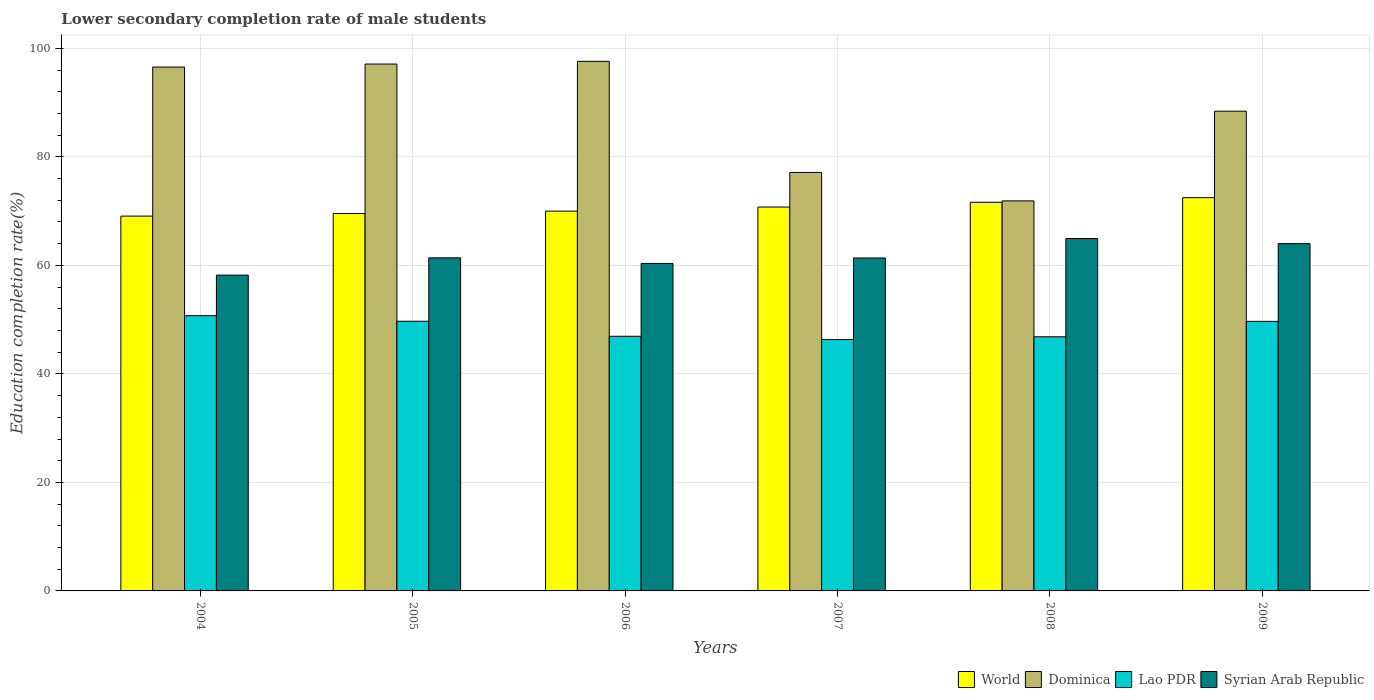How many groups of bars are there?
Your response must be concise. 6. In how many cases, is the number of bars for a given year not equal to the number of legend labels?
Offer a very short reply. 0. What is the lower secondary completion rate of male students in Lao PDR in 2009?
Provide a succinct answer. 49.68. Across all years, what is the maximum lower secondary completion rate of male students in Syrian Arab Republic?
Offer a terse response. 64.95. Across all years, what is the minimum lower secondary completion rate of male students in Dominica?
Ensure brevity in your answer.  71.89. In which year was the lower secondary completion rate of male students in World minimum?
Keep it short and to the point. 2004. What is the total lower secondary completion rate of male students in Dominica in the graph?
Offer a very short reply. 528.71. What is the difference between the lower secondary completion rate of male students in World in 2005 and that in 2009?
Your answer should be compact. -2.91. What is the difference between the lower secondary completion rate of male students in Dominica in 2005 and the lower secondary completion rate of male students in World in 2006?
Offer a terse response. 27.11. What is the average lower secondary completion rate of male students in World per year?
Ensure brevity in your answer.  70.58. In the year 2009, what is the difference between the lower secondary completion rate of male students in Dominica and lower secondary completion rate of male students in World?
Give a very brief answer. 15.95. In how many years, is the lower secondary completion rate of male students in Syrian Arab Republic greater than 52 %?
Provide a short and direct response. 6. What is the ratio of the lower secondary completion rate of male students in Lao PDR in 2005 to that in 2006?
Ensure brevity in your answer.  1.06. Is the lower secondary completion rate of male students in World in 2008 less than that in 2009?
Offer a very short reply. Yes. What is the difference between the highest and the second highest lower secondary completion rate of male students in Syrian Arab Republic?
Give a very brief answer. 0.94. What is the difference between the highest and the lowest lower secondary completion rate of male students in Syrian Arab Republic?
Provide a short and direct response. 6.74. In how many years, is the lower secondary completion rate of male students in Syrian Arab Republic greater than the average lower secondary completion rate of male students in Syrian Arab Republic taken over all years?
Your response must be concise. 2. What does the 2nd bar from the left in 2005 represents?
Offer a very short reply. Dominica. What does the 2nd bar from the right in 2006 represents?
Your response must be concise. Lao PDR. How many bars are there?
Make the answer very short. 24. Are all the bars in the graph horizontal?
Give a very brief answer. No. Does the graph contain any zero values?
Provide a succinct answer. No. How many legend labels are there?
Keep it short and to the point. 4. How are the legend labels stacked?
Provide a succinct answer. Horizontal. What is the title of the graph?
Provide a short and direct response. Lower secondary completion rate of male students. Does "Lao PDR" appear as one of the legend labels in the graph?
Give a very brief answer. Yes. What is the label or title of the Y-axis?
Offer a very short reply. Education completion rate(%). What is the Education completion rate(%) in World in 2004?
Keep it short and to the point. 69.08. What is the Education completion rate(%) of Dominica in 2004?
Make the answer very short. 96.56. What is the Education completion rate(%) in Lao PDR in 2004?
Provide a short and direct response. 50.73. What is the Education completion rate(%) of Syrian Arab Republic in 2004?
Your response must be concise. 58.21. What is the Education completion rate(%) of World in 2005?
Provide a succinct answer. 69.56. What is the Education completion rate(%) in Dominica in 2005?
Your answer should be very brief. 97.11. What is the Education completion rate(%) of Lao PDR in 2005?
Your answer should be compact. 49.7. What is the Education completion rate(%) in Syrian Arab Republic in 2005?
Your response must be concise. 61.39. What is the Education completion rate(%) of World in 2006?
Offer a terse response. 70. What is the Education completion rate(%) of Dominica in 2006?
Offer a very short reply. 97.6. What is the Education completion rate(%) in Lao PDR in 2006?
Your response must be concise. 46.93. What is the Education completion rate(%) of Syrian Arab Republic in 2006?
Offer a terse response. 60.36. What is the Education completion rate(%) of World in 2007?
Your answer should be very brief. 70.75. What is the Education completion rate(%) of Dominica in 2007?
Offer a terse response. 77.13. What is the Education completion rate(%) in Lao PDR in 2007?
Provide a succinct answer. 46.33. What is the Education completion rate(%) of Syrian Arab Republic in 2007?
Keep it short and to the point. 61.36. What is the Education completion rate(%) of World in 2008?
Provide a short and direct response. 71.63. What is the Education completion rate(%) in Dominica in 2008?
Ensure brevity in your answer.  71.89. What is the Education completion rate(%) in Lao PDR in 2008?
Your answer should be compact. 46.84. What is the Education completion rate(%) of Syrian Arab Republic in 2008?
Provide a short and direct response. 64.95. What is the Education completion rate(%) of World in 2009?
Ensure brevity in your answer.  72.48. What is the Education completion rate(%) of Dominica in 2009?
Keep it short and to the point. 88.42. What is the Education completion rate(%) of Lao PDR in 2009?
Make the answer very short. 49.68. What is the Education completion rate(%) of Syrian Arab Republic in 2009?
Make the answer very short. 64.01. Across all years, what is the maximum Education completion rate(%) of World?
Your response must be concise. 72.48. Across all years, what is the maximum Education completion rate(%) of Dominica?
Your response must be concise. 97.6. Across all years, what is the maximum Education completion rate(%) in Lao PDR?
Ensure brevity in your answer.  50.73. Across all years, what is the maximum Education completion rate(%) in Syrian Arab Republic?
Provide a short and direct response. 64.95. Across all years, what is the minimum Education completion rate(%) in World?
Your answer should be very brief. 69.08. Across all years, what is the minimum Education completion rate(%) of Dominica?
Give a very brief answer. 71.89. Across all years, what is the minimum Education completion rate(%) of Lao PDR?
Keep it short and to the point. 46.33. Across all years, what is the minimum Education completion rate(%) in Syrian Arab Republic?
Your answer should be compact. 58.21. What is the total Education completion rate(%) of World in the graph?
Offer a very short reply. 423.51. What is the total Education completion rate(%) in Dominica in the graph?
Provide a short and direct response. 528.71. What is the total Education completion rate(%) in Lao PDR in the graph?
Your answer should be compact. 290.22. What is the total Education completion rate(%) in Syrian Arab Republic in the graph?
Provide a succinct answer. 370.28. What is the difference between the Education completion rate(%) in World in 2004 and that in 2005?
Give a very brief answer. -0.48. What is the difference between the Education completion rate(%) of Dominica in 2004 and that in 2005?
Make the answer very short. -0.55. What is the difference between the Education completion rate(%) in Lao PDR in 2004 and that in 2005?
Your response must be concise. 1.03. What is the difference between the Education completion rate(%) of Syrian Arab Republic in 2004 and that in 2005?
Give a very brief answer. -3.18. What is the difference between the Education completion rate(%) of World in 2004 and that in 2006?
Ensure brevity in your answer.  -0.92. What is the difference between the Education completion rate(%) of Dominica in 2004 and that in 2006?
Your answer should be compact. -1.05. What is the difference between the Education completion rate(%) of Lao PDR in 2004 and that in 2006?
Your answer should be very brief. 3.8. What is the difference between the Education completion rate(%) in Syrian Arab Republic in 2004 and that in 2006?
Your answer should be compact. -2.15. What is the difference between the Education completion rate(%) in World in 2004 and that in 2007?
Provide a short and direct response. -1.66. What is the difference between the Education completion rate(%) of Dominica in 2004 and that in 2007?
Ensure brevity in your answer.  19.42. What is the difference between the Education completion rate(%) in Lao PDR in 2004 and that in 2007?
Your answer should be compact. 4.4. What is the difference between the Education completion rate(%) of Syrian Arab Republic in 2004 and that in 2007?
Your answer should be compact. -3.16. What is the difference between the Education completion rate(%) of World in 2004 and that in 2008?
Your answer should be compact. -2.55. What is the difference between the Education completion rate(%) of Dominica in 2004 and that in 2008?
Give a very brief answer. 24.67. What is the difference between the Education completion rate(%) in Lao PDR in 2004 and that in 2008?
Provide a short and direct response. 3.89. What is the difference between the Education completion rate(%) in Syrian Arab Republic in 2004 and that in 2008?
Your response must be concise. -6.74. What is the difference between the Education completion rate(%) in World in 2004 and that in 2009?
Give a very brief answer. -3.39. What is the difference between the Education completion rate(%) in Dominica in 2004 and that in 2009?
Give a very brief answer. 8.14. What is the difference between the Education completion rate(%) of Lao PDR in 2004 and that in 2009?
Give a very brief answer. 1.05. What is the difference between the Education completion rate(%) of Syrian Arab Republic in 2004 and that in 2009?
Keep it short and to the point. -5.8. What is the difference between the Education completion rate(%) of World in 2005 and that in 2006?
Ensure brevity in your answer.  -0.44. What is the difference between the Education completion rate(%) of Dominica in 2005 and that in 2006?
Keep it short and to the point. -0.5. What is the difference between the Education completion rate(%) in Lao PDR in 2005 and that in 2006?
Give a very brief answer. 2.77. What is the difference between the Education completion rate(%) of Syrian Arab Republic in 2005 and that in 2006?
Your answer should be very brief. 1.03. What is the difference between the Education completion rate(%) of World in 2005 and that in 2007?
Make the answer very short. -1.18. What is the difference between the Education completion rate(%) in Dominica in 2005 and that in 2007?
Keep it short and to the point. 19.98. What is the difference between the Education completion rate(%) of Lao PDR in 2005 and that in 2007?
Your response must be concise. 3.38. What is the difference between the Education completion rate(%) of Syrian Arab Republic in 2005 and that in 2007?
Your answer should be very brief. 0.02. What is the difference between the Education completion rate(%) in World in 2005 and that in 2008?
Make the answer very short. -2.07. What is the difference between the Education completion rate(%) of Dominica in 2005 and that in 2008?
Give a very brief answer. 25.22. What is the difference between the Education completion rate(%) in Lao PDR in 2005 and that in 2008?
Your answer should be compact. 2.86. What is the difference between the Education completion rate(%) of Syrian Arab Republic in 2005 and that in 2008?
Ensure brevity in your answer.  -3.56. What is the difference between the Education completion rate(%) of World in 2005 and that in 2009?
Your answer should be very brief. -2.91. What is the difference between the Education completion rate(%) of Dominica in 2005 and that in 2009?
Your answer should be very brief. 8.69. What is the difference between the Education completion rate(%) in Lao PDR in 2005 and that in 2009?
Your answer should be compact. 0.02. What is the difference between the Education completion rate(%) in Syrian Arab Republic in 2005 and that in 2009?
Offer a very short reply. -2.62. What is the difference between the Education completion rate(%) in World in 2006 and that in 2007?
Your response must be concise. -0.75. What is the difference between the Education completion rate(%) in Dominica in 2006 and that in 2007?
Offer a very short reply. 20.47. What is the difference between the Education completion rate(%) of Lao PDR in 2006 and that in 2007?
Your answer should be compact. 0.61. What is the difference between the Education completion rate(%) of Syrian Arab Republic in 2006 and that in 2007?
Keep it short and to the point. -1.01. What is the difference between the Education completion rate(%) of World in 2006 and that in 2008?
Offer a very short reply. -1.63. What is the difference between the Education completion rate(%) of Dominica in 2006 and that in 2008?
Provide a short and direct response. 25.72. What is the difference between the Education completion rate(%) of Lao PDR in 2006 and that in 2008?
Keep it short and to the point. 0.09. What is the difference between the Education completion rate(%) of Syrian Arab Republic in 2006 and that in 2008?
Your answer should be compact. -4.59. What is the difference between the Education completion rate(%) in World in 2006 and that in 2009?
Your answer should be very brief. -2.47. What is the difference between the Education completion rate(%) of Dominica in 2006 and that in 2009?
Keep it short and to the point. 9.18. What is the difference between the Education completion rate(%) of Lao PDR in 2006 and that in 2009?
Your response must be concise. -2.75. What is the difference between the Education completion rate(%) of Syrian Arab Republic in 2006 and that in 2009?
Offer a terse response. -3.65. What is the difference between the Education completion rate(%) of World in 2007 and that in 2008?
Offer a very short reply. -0.88. What is the difference between the Education completion rate(%) in Dominica in 2007 and that in 2008?
Offer a very short reply. 5.24. What is the difference between the Education completion rate(%) in Lao PDR in 2007 and that in 2008?
Your answer should be compact. -0.52. What is the difference between the Education completion rate(%) of Syrian Arab Republic in 2007 and that in 2008?
Your answer should be compact. -3.59. What is the difference between the Education completion rate(%) in World in 2007 and that in 2009?
Provide a succinct answer. -1.73. What is the difference between the Education completion rate(%) in Dominica in 2007 and that in 2009?
Provide a succinct answer. -11.29. What is the difference between the Education completion rate(%) in Lao PDR in 2007 and that in 2009?
Offer a very short reply. -3.35. What is the difference between the Education completion rate(%) of Syrian Arab Republic in 2007 and that in 2009?
Give a very brief answer. -2.65. What is the difference between the Education completion rate(%) of World in 2008 and that in 2009?
Your response must be concise. -0.84. What is the difference between the Education completion rate(%) of Dominica in 2008 and that in 2009?
Your answer should be compact. -16.53. What is the difference between the Education completion rate(%) in Lao PDR in 2008 and that in 2009?
Ensure brevity in your answer.  -2.84. What is the difference between the Education completion rate(%) of Syrian Arab Republic in 2008 and that in 2009?
Make the answer very short. 0.94. What is the difference between the Education completion rate(%) of World in 2004 and the Education completion rate(%) of Dominica in 2005?
Your answer should be compact. -28.02. What is the difference between the Education completion rate(%) of World in 2004 and the Education completion rate(%) of Lao PDR in 2005?
Your answer should be very brief. 19.38. What is the difference between the Education completion rate(%) in World in 2004 and the Education completion rate(%) in Syrian Arab Republic in 2005?
Your answer should be very brief. 7.69. What is the difference between the Education completion rate(%) in Dominica in 2004 and the Education completion rate(%) in Lao PDR in 2005?
Your answer should be compact. 46.85. What is the difference between the Education completion rate(%) in Dominica in 2004 and the Education completion rate(%) in Syrian Arab Republic in 2005?
Ensure brevity in your answer.  35.17. What is the difference between the Education completion rate(%) of Lao PDR in 2004 and the Education completion rate(%) of Syrian Arab Republic in 2005?
Provide a succinct answer. -10.66. What is the difference between the Education completion rate(%) of World in 2004 and the Education completion rate(%) of Dominica in 2006?
Your answer should be compact. -28.52. What is the difference between the Education completion rate(%) of World in 2004 and the Education completion rate(%) of Lao PDR in 2006?
Offer a very short reply. 22.15. What is the difference between the Education completion rate(%) in World in 2004 and the Education completion rate(%) in Syrian Arab Republic in 2006?
Provide a short and direct response. 8.73. What is the difference between the Education completion rate(%) of Dominica in 2004 and the Education completion rate(%) of Lao PDR in 2006?
Your answer should be very brief. 49.62. What is the difference between the Education completion rate(%) in Dominica in 2004 and the Education completion rate(%) in Syrian Arab Republic in 2006?
Offer a terse response. 36.2. What is the difference between the Education completion rate(%) in Lao PDR in 2004 and the Education completion rate(%) in Syrian Arab Republic in 2006?
Your answer should be compact. -9.63. What is the difference between the Education completion rate(%) in World in 2004 and the Education completion rate(%) in Dominica in 2007?
Offer a terse response. -8.05. What is the difference between the Education completion rate(%) of World in 2004 and the Education completion rate(%) of Lao PDR in 2007?
Ensure brevity in your answer.  22.76. What is the difference between the Education completion rate(%) of World in 2004 and the Education completion rate(%) of Syrian Arab Republic in 2007?
Offer a terse response. 7.72. What is the difference between the Education completion rate(%) of Dominica in 2004 and the Education completion rate(%) of Lao PDR in 2007?
Make the answer very short. 50.23. What is the difference between the Education completion rate(%) in Dominica in 2004 and the Education completion rate(%) in Syrian Arab Republic in 2007?
Provide a short and direct response. 35.19. What is the difference between the Education completion rate(%) of Lao PDR in 2004 and the Education completion rate(%) of Syrian Arab Republic in 2007?
Provide a succinct answer. -10.63. What is the difference between the Education completion rate(%) in World in 2004 and the Education completion rate(%) in Dominica in 2008?
Offer a terse response. -2.8. What is the difference between the Education completion rate(%) in World in 2004 and the Education completion rate(%) in Lao PDR in 2008?
Provide a short and direct response. 22.24. What is the difference between the Education completion rate(%) in World in 2004 and the Education completion rate(%) in Syrian Arab Republic in 2008?
Keep it short and to the point. 4.13. What is the difference between the Education completion rate(%) of Dominica in 2004 and the Education completion rate(%) of Lao PDR in 2008?
Provide a succinct answer. 49.71. What is the difference between the Education completion rate(%) in Dominica in 2004 and the Education completion rate(%) in Syrian Arab Republic in 2008?
Offer a very short reply. 31.61. What is the difference between the Education completion rate(%) of Lao PDR in 2004 and the Education completion rate(%) of Syrian Arab Republic in 2008?
Your answer should be very brief. -14.22. What is the difference between the Education completion rate(%) in World in 2004 and the Education completion rate(%) in Dominica in 2009?
Ensure brevity in your answer.  -19.34. What is the difference between the Education completion rate(%) in World in 2004 and the Education completion rate(%) in Lao PDR in 2009?
Make the answer very short. 19.4. What is the difference between the Education completion rate(%) in World in 2004 and the Education completion rate(%) in Syrian Arab Republic in 2009?
Offer a terse response. 5.07. What is the difference between the Education completion rate(%) of Dominica in 2004 and the Education completion rate(%) of Lao PDR in 2009?
Provide a short and direct response. 46.88. What is the difference between the Education completion rate(%) of Dominica in 2004 and the Education completion rate(%) of Syrian Arab Republic in 2009?
Provide a short and direct response. 32.55. What is the difference between the Education completion rate(%) in Lao PDR in 2004 and the Education completion rate(%) in Syrian Arab Republic in 2009?
Provide a short and direct response. -13.28. What is the difference between the Education completion rate(%) in World in 2005 and the Education completion rate(%) in Dominica in 2006?
Your answer should be compact. -28.04. What is the difference between the Education completion rate(%) in World in 2005 and the Education completion rate(%) in Lao PDR in 2006?
Offer a terse response. 22.63. What is the difference between the Education completion rate(%) in World in 2005 and the Education completion rate(%) in Syrian Arab Republic in 2006?
Offer a terse response. 9.21. What is the difference between the Education completion rate(%) of Dominica in 2005 and the Education completion rate(%) of Lao PDR in 2006?
Your answer should be compact. 50.17. What is the difference between the Education completion rate(%) of Dominica in 2005 and the Education completion rate(%) of Syrian Arab Republic in 2006?
Offer a terse response. 36.75. What is the difference between the Education completion rate(%) of Lao PDR in 2005 and the Education completion rate(%) of Syrian Arab Republic in 2006?
Offer a very short reply. -10.65. What is the difference between the Education completion rate(%) in World in 2005 and the Education completion rate(%) in Dominica in 2007?
Offer a terse response. -7.57. What is the difference between the Education completion rate(%) in World in 2005 and the Education completion rate(%) in Lao PDR in 2007?
Provide a short and direct response. 23.24. What is the difference between the Education completion rate(%) of World in 2005 and the Education completion rate(%) of Syrian Arab Republic in 2007?
Provide a short and direct response. 8.2. What is the difference between the Education completion rate(%) in Dominica in 2005 and the Education completion rate(%) in Lao PDR in 2007?
Keep it short and to the point. 50.78. What is the difference between the Education completion rate(%) in Dominica in 2005 and the Education completion rate(%) in Syrian Arab Republic in 2007?
Provide a succinct answer. 35.74. What is the difference between the Education completion rate(%) of Lao PDR in 2005 and the Education completion rate(%) of Syrian Arab Republic in 2007?
Provide a succinct answer. -11.66. What is the difference between the Education completion rate(%) in World in 2005 and the Education completion rate(%) in Dominica in 2008?
Give a very brief answer. -2.32. What is the difference between the Education completion rate(%) in World in 2005 and the Education completion rate(%) in Lao PDR in 2008?
Your answer should be very brief. 22.72. What is the difference between the Education completion rate(%) of World in 2005 and the Education completion rate(%) of Syrian Arab Republic in 2008?
Provide a short and direct response. 4.61. What is the difference between the Education completion rate(%) of Dominica in 2005 and the Education completion rate(%) of Lao PDR in 2008?
Offer a very short reply. 50.26. What is the difference between the Education completion rate(%) of Dominica in 2005 and the Education completion rate(%) of Syrian Arab Republic in 2008?
Your answer should be compact. 32.16. What is the difference between the Education completion rate(%) of Lao PDR in 2005 and the Education completion rate(%) of Syrian Arab Republic in 2008?
Provide a short and direct response. -15.25. What is the difference between the Education completion rate(%) of World in 2005 and the Education completion rate(%) of Dominica in 2009?
Provide a short and direct response. -18.86. What is the difference between the Education completion rate(%) in World in 2005 and the Education completion rate(%) in Lao PDR in 2009?
Make the answer very short. 19.88. What is the difference between the Education completion rate(%) of World in 2005 and the Education completion rate(%) of Syrian Arab Republic in 2009?
Offer a very short reply. 5.55. What is the difference between the Education completion rate(%) in Dominica in 2005 and the Education completion rate(%) in Lao PDR in 2009?
Provide a succinct answer. 47.43. What is the difference between the Education completion rate(%) in Dominica in 2005 and the Education completion rate(%) in Syrian Arab Republic in 2009?
Ensure brevity in your answer.  33.1. What is the difference between the Education completion rate(%) in Lao PDR in 2005 and the Education completion rate(%) in Syrian Arab Republic in 2009?
Ensure brevity in your answer.  -14.31. What is the difference between the Education completion rate(%) of World in 2006 and the Education completion rate(%) of Dominica in 2007?
Provide a succinct answer. -7.13. What is the difference between the Education completion rate(%) in World in 2006 and the Education completion rate(%) in Lao PDR in 2007?
Your answer should be compact. 23.67. What is the difference between the Education completion rate(%) in World in 2006 and the Education completion rate(%) in Syrian Arab Republic in 2007?
Your answer should be compact. 8.64. What is the difference between the Education completion rate(%) of Dominica in 2006 and the Education completion rate(%) of Lao PDR in 2007?
Your response must be concise. 51.28. What is the difference between the Education completion rate(%) in Dominica in 2006 and the Education completion rate(%) in Syrian Arab Republic in 2007?
Your answer should be compact. 36.24. What is the difference between the Education completion rate(%) of Lao PDR in 2006 and the Education completion rate(%) of Syrian Arab Republic in 2007?
Give a very brief answer. -14.43. What is the difference between the Education completion rate(%) of World in 2006 and the Education completion rate(%) of Dominica in 2008?
Provide a short and direct response. -1.89. What is the difference between the Education completion rate(%) in World in 2006 and the Education completion rate(%) in Lao PDR in 2008?
Your answer should be compact. 23.16. What is the difference between the Education completion rate(%) in World in 2006 and the Education completion rate(%) in Syrian Arab Republic in 2008?
Provide a short and direct response. 5.05. What is the difference between the Education completion rate(%) in Dominica in 2006 and the Education completion rate(%) in Lao PDR in 2008?
Ensure brevity in your answer.  50.76. What is the difference between the Education completion rate(%) of Dominica in 2006 and the Education completion rate(%) of Syrian Arab Republic in 2008?
Ensure brevity in your answer.  32.65. What is the difference between the Education completion rate(%) in Lao PDR in 2006 and the Education completion rate(%) in Syrian Arab Republic in 2008?
Ensure brevity in your answer.  -18.02. What is the difference between the Education completion rate(%) in World in 2006 and the Education completion rate(%) in Dominica in 2009?
Provide a short and direct response. -18.42. What is the difference between the Education completion rate(%) of World in 2006 and the Education completion rate(%) of Lao PDR in 2009?
Your answer should be very brief. 20.32. What is the difference between the Education completion rate(%) in World in 2006 and the Education completion rate(%) in Syrian Arab Republic in 2009?
Give a very brief answer. 5.99. What is the difference between the Education completion rate(%) in Dominica in 2006 and the Education completion rate(%) in Lao PDR in 2009?
Your response must be concise. 47.92. What is the difference between the Education completion rate(%) of Dominica in 2006 and the Education completion rate(%) of Syrian Arab Republic in 2009?
Ensure brevity in your answer.  33.59. What is the difference between the Education completion rate(%) of Lao PDR in 2006 and the Education completion rate(%) of Syrian Arab Republic in 2009?
Ensure brevity in your answer.  -17.08. What is the difference between the Education completion rate(%) of World in 2007 and the Education completion rate(%) of Dominica in 2008?
Your answer should be very brief. -1.14. What is the difference between the Education completion rate(%) of World in 2007 and the Education completion rate(%) of Lao PDR in 2008?
Provide a succinct answer. 23.91. What is the difference between the Education completion rate(%) of World in 2007 and the Education completion rate(%) of Syrian Arab Republic in 2008?
Offer a terse response. 5.8. What is the difference between the Education completion rate(%) of Dominica in 2007 and the Education completion rate(%) of Lao PDR in 2008?
Give a very brief answer. 30.29. What is the difference between the Education completion rate(%) in Dominica in 2007 and the Education completion rate(%) in Syrian Arab Republic in 2008?
Offer a very short reply. 12.18. What is the difference between the Education completion rate(%) in Lao PDR in 2007 and the Education completion rate(%) in Syrian Arab Republic in 2008?
Your answer should be very brief. -18.62. What is the difference between the Education completion rate(%) in World in 2007 and the Education completion rate(%) in Dominica in 2009?
Give a very brief answer. -17.67. What is the difference between the Education completion rate(%) in World in 2007 and the Education completion rate(%) in Lao PDR in 2009?
Keep it short and to the point. 21.07. What is the difference between the Education completion rate(%) in World in 2007 and the Education completion rate(%) in Syrian Arab Republic in 2009?
Give a very brief answer. 6.74. What is the difference between the Education completion rate(%) in Dominica in 2007 and the Education completion rate(%) in Lao PDR in 2009?
Your answer should be compact. 27.45. What is the difference between the Education completion rate(%) of Dominica in 2007 and the Education completion rate(%) of Syrian Arab Republic in 2009?
Give a very brief answer. 13.12. What is the difference between the Education completion rate(%) in Lao PDR in 2007 and the Education completion rate(%) in Syrian Arab Republic in 2009?
Ensure brevity in your answer.  -17.68. What is the difference between the Education completion rate(%) in World in 2008 and the Education completion rate(%) in Dominica in 2009?
Your response must be concise. -16.79. What is the difference between the Education completion rate(%) in World in 2008 and the Education completion rate(%) in Lao PDR in 2009?
Give a very brief answer. 21.95. What is the difference between the Education completion rate(%) of World in 2008 and the Education completion rate(%) of Syrian Arab Republic in 2009?
Keep it short and to the point. 7.62. What is the difference between the Education completion rate(%) of Dominica in 2008 and the Education completion rate(%) of Lao PDR in 2009?
Your response must be concise. 22.21. What is the difference between the Education completion rate(%) of Dominica in 2008 and the Education completion rate(%) of Syrian Arab Republic in 2009?
Your answer should be very brief. 7.88. What is the difference between the Education completion rate(%) of Lao PDR in 2008 and the Education completion rate(%) of Syrian Arab Republic in 2009?
Give a very brief answer. -17.17. What is the average Education completion rate(%) in World per year?
Provide a short and direct response. 70.58. What is the average Education completion rate(%) in Dominica per year?
Provide a short and direct response. 88.12. What is the average Education completion rate(%) in Lao PDR per year?
Offer a terse response. 48.37. What is the average Education completion rate(%) in Syrian Arab Republic per year?
Offer a terse response. 61.71. In the year 2004, what is the difference between the Education completion rate(%) in World and Education completion rate(%) in Dominica?
Keep it short and to the point. -27.47. In the year 2004, what is the difference between the Education completion rate(%) in World and Education completion rate(%) in Lao PDR?
Provide a short and direct response. 18.35. In the year 2004, what is the difference between the Education completion rate(%) in World and Education completion rate(%) in Syrian Arab Republic?
Make the answer very short. 10.88. In the year 2004, what is the difference between the Education completion rate(%) in Dominica and Education completion rate(%) in Lao PDR?
Offer a very short reply. 45.83. In the year 2004, what is the difference between the Education completion rate(%) of Dominica and Education completion rate(%) of Syrian Arab Republic?
Provide a succinct answer. 38.35. In the year 2004, what is the difference between the Education completion rate(%) of Lao PDR and Education completion rate(%) of Syrian Arab Republic?
Make the answer very short. -7.47. In the year 2005, what is the difference between the Education completion rate(%) of World and Education completion rate(%) of Dominica?
Give a very brief answer. -27.54. In the year 2005, what is the difference between the Education completion rate(%) in World and Education completion rate(%) in Lao PDR?
Offer a terse response. 19.86. In the year 2005, what is the difference between the Education completion rate(%) of World and Education completion rate(%) of Syrian Arab Republic?
Give a very brief answer. 8.18. In the year 2005, what is the difference between the Education completion rate(%) of Dominica and Education completion rate(%) of Lao PDR?
Ensure brevity in your answer.  47.4. In the year 2005, what is the difference between the Education completion rate(%) in Dominica and Education completion rate(%) in Syrian Arab Republic?
Your answer should be compact. 35.72. In the year 2005, what is the difference between the Education completion rate(%) of Lao PDR and Education completion rate(%) of Syrian Arab Republic?
Give a very brief answer. -11.68. In the year 2006, what is the difference between the Education completion rate(%) of World and Education completion rate(%) of Dominica?
Offer a very short reply. -27.6. In the year 2006, what is the difference between the Education completion rate(%) in World and Education completion rate(%) in Lao PDR?
Give a very brief answer. 23.07. In the year 2006, what is the difference between the Education completion rate(%) of World and Education completion rate(%) of Syrian Arab Republic?
Provide a succinct answer. 9.64. In the year 2006, what is the difference between the Education completion rate(%) in Dominica and Education completion rate(%) in Lao PDR?
Your response must be concise. 50.67. In the year 2006, what is the difference between the Education completion rate(%) in Dominica and Education completion rate(%) in Syrian Arab Republic?
Provide a short and direct response. 37.25. In the year 2006, what is the difference between the Education completion rate(%) of Lao PDR and Education completion rate(%) of Syrian Arab Republic?
Give a very brief answer. -13.42. In the year 2007, what is the difference between the Education completion rate(%) in World and Education completion rate(%) in Dominica?
Your answer should be compact. -6.38. In the year 2007, what is the difference between the Education completion rate(%) of World and Education completion rate(%) of Lao PDR?
Offer a very short reply. 24.42. In the year 2007, what is the difference between the Education completion rate(%) in World and Education completion rate(%) in Syrian Arab Republic?
Your answer should be compact. 9.38. In the year 2007, what is the difference between the Education completion rate(%) of Dominica and Education completion rate(%) of Lao PDR?
Your answer should be very brief. 30.8. In the year 2007, what is the difference between the Education completion rate(%) of Dominica and Education completion rate(%) of Syrian Arab Republic?
Ensure brevity in your answer.  15.77. In the year 2007, what is the difference between the Education completion rate(%) in Lao PDR and Education completion rate(%) in Syrian Arab Republic?
Keep it short and to the point. -15.04. In the year 2008, what is the difference between the Education completion rate(%) of World and Education completion rate(%) of Dominica?
Your answer should be very brief. -0.26. In the year 2008, what is the difference between the Education completion rate(%) in World and Education completion rate(%) in Lao PDR?
Offer a terse response. 24.79. In the year 2008, what is the difference between the Education completion rate(%) of World and Education completion rate(%) of Syrian Arab Republic?
Your answer should be compact. 6.68. In the year 2008, what is the difference between the Education completion rate(%) in Dominica and Education completion rate(%) in Lao PDR?
Make the answer very short. 25.04. In the year 2008, what is the difference between the Education completion rate(%) in Dominica and Education completion rate(%) in Syrian Arab Republic?
Your answer should be very brief. 6.94. In the year 2008, what is the difference between the Education completion rate(%) in Lao PDR and Education completion rate(%) in Syrian Arab Republic?
Make the answer very short. -18.11. In the year 2009, what is the difference between the Education completion rate(%) in World and Education completion rate(%) in Dominica?
Ensure brevity in your answer.  -15.95. In the year 2009, what is the difference between the Education completion rate(%) in World and Education completion rate(%) in Lao PDR?
Provide a short and direct response. 22.8. In the year 2009, what is the difference between the Education completion rate(%) in World and Education completion rate(%) in Syrian Arab Republic?
Your answer should be compact. 8.47. In the year 2009, what is the difference between the Education completion rate(%) in Dominica and Education completion rate(%) in Lao PDR?
Keep it short and to the point. 38.74. In the year 2009, what is the difference between the Education completion rate(%) in Dominica and Education completion rate(%) in Syrian Arab Republic?
Give a very brief answer. 24.41. In the year 2009, what is the difference between the Education completion rate(%) in Lao PDR and Education completion rate(%) in Syrian Arab Republic?
Make the answer very short. -14.33. What is the ratio of the Education completion rate(%) in Lao PDR in 2004 to that in 2005?
Your response must be concise. 1.02. What is the ratio of the Education completion rate(%) of Syrian Arab Republic in 2004 to that in 2005?
Your answer should be compact. 0.95. What is the ratio of the Education completion rate(%) of World in 2004 to that in 2006?
Provide a short and direct response. 0.99. What is the ratio of the Education completion rate(%) of Dominica in 2004 to that in 2006?
Offer a terse response. 0.99. What is the ratio of the Education completion rate(%) of Lao PDR in 2004 to that in 2006?
Give a very brief answer. 1.08. What is the ratio of the Education completion rate(%) of Syrian Arab Republic in 2004 to that in 2006?
Provide a succinct answer. 0.96. What is the ratio of the Education completion rate(%) of World in 2004 to that in 2007?
Make the answer very short. 0.98. What is the ratio of the Education completion rate(%) of Dominica in 2004 to that in 2007?
Keep it short and to the point. 1.25. What is the ratio of the Education completion rate(%) in Lao PDR in 2004 to that in 2007?
Give a very brief answer. 1.1. What is the ratio of the Education completion rate(%) of Syrian Arab Republic in 2004 to that in 2007?
Offer a very short reply. 0.95. What is the ratio of the Education completion rate(%) in World in 2004 to that in 2008?
Ensure brevity in your answer.  0.96. What is the ratio of the Education completion rate(%) in Dominica in 2004 to that in 2008?
Your answer should be compact. 1.34. What is the ratio of the Education completion rate(%) in Lao PDR in 2004 to that in 2008?
Offer a very short reply. 1.08. What is the ratio of the Education completion rate(%) of Syrian Arab Republic in 2004 to that in 2008?
Your answer should be compact. 0.9. What is the ratio of the Education completion rate(%) in World in 2004 to that in 2009?
Your answer should be compact. 0.95. What is the ratio of the Education completion rate(%) in Dominica in 2004 to that in 2009?
Provide a succinct answer. 1.09. What is the ratio of the Education completion rate(%) of Lao PDR in 2004 to that in 2009?
Your response must be concise. 1.02. What is the ratio of the Education completion rate(%) of Syrian Arab Republic in 2004 to that in 2009?
Give a very brief answer. 0.91. What is the ratio of the Education completion rate(%) in Dominica in 2005 to that in 2006?
Ensure brevity in your answer.  0.99. What is the ratio of the Education completion rate(%) in Lao PDR in 2005 to that in 2006?
Keep it short and to the point. 1.06. What is the ratio of the Education completion rate(%) of Syrian Arab Republic in 2005 to that in 2006?
Ensure brevity in your answer.  1.02. What is the ratio of the Education completion rate(%) in World in 2005 to that in 2007?
Ensure brevity in your answer.  0.98. What is the ratio of the Education completion rate(%) in Dominica in 2005 to that in 2007?
Keep it short and to the point. 1.26. What is the ratio of the Education completion rate(%) in Lao PDR in 2005 to that in 2007?
Give a very brief answer. 1.07. What is the ratio of the Education completion rate(%) of World in 2005 to that in 2008?
Give a very brief answer. 0.97. What is the ratio of the Education completion rate(%) of Dominica in 2005 to that in 2008?
Keep it short and to the point. 1.35. What is the ratio of the Education completion rate(%) in Lao PDR in 2005 to that in 2008?
Make the answer very short. 1.06. What is the ratio of the Education completion rate(%) in Syrian Arab Republic in 2005 to that in 2008?
Your response must be concise. 0.95. What is the ratio of the Education completion rate(%) of World in 2005 to that in 2009?
Your response must be concise. 0.96. What is the ratio of the Education completion rate(%) in Dominica in 2005 to that in 2009?
Your answer should be compact. 1.1. What is the ratio of the Education completion rate(%) of Syrian Arab Republic in 2005 to that in 2009?
Give a very brief answer. 0.96. What is the ratio of the Education completion rate(%) of World in 2006 to that in 2007?
Your answer should be very brief. 0.99. What is the ratio of the Education completion rate(%) of Dominica in 2006 to that in 2007?
Make the answer very short. 1.27. What is the ratio of the Education completion rate(%) in Lao PDR in 2006 to that in 2007?
Your answer should be very brief. 1.01. What is the ratio of the Education completion rate(%) of Syrian Arab Republic in 2006 to that in 2007?
Your answer should be compact. 0.98. What is the ratio of the Education completion rate(%) in World in 2006 to that in 2008?
Your response must be concise. 0.98. What is the ratio of the Education completion rate(%) in Dominica in 2006 to that in 2008?
Your response must be concise. 1.36. What is the ratio of the Education completion rate(%) of Lao PDR in 2006 to that in 2008?
Your response must be concise. 1. What is the ratio of the Education completion rate(%) in Syrian Arab Republic in 2006 to that in 2008?
Offer a terse response. 0.93. What is the ratio of the Education completion rate(%) in World in 2006 to that in 2009?
Your answer should be compact. 0.97. What is the ratio of the Education completion rate(%) of Dominica in 2006 to that in 2009?
Provide a succinct answer. 1.1. What is the ratio of the Education completion rate(%) in Lao PDR in 2006 to that in 2009?
Keep it short and to the point. 0.94. What is the ratio of the Education completion rate(%) in Syrian Arab Republic in 2006 to that in 2009?
Provide a short and direct response. 0.94. What is the ratio of the Education completion rate(%) of World in 2007 to that in 2008?
Offer a very short reply. 0.99. What is the ratio of the Education completion rate(%) in Dominica in 2007 to that in 2008?
Provide a short and direct response. 1.07. What is the ratio of the Education completion rate(%) in Lao PDR in 2007 to that in 2008?
Your response must be concise. 0.99. What is the ratio of the Education completion rate(%) in Syrian Arab Republic in 2007 to that in 2008?
Your answer should be very brief. 0.94. What is the ratio of the Education completion rate(%) of World in 2007 to that in 2009?
Give a very brief answer. 0.98. What is the ratio of the Education completion rate(%) of Dominica in 2007 to that in 2009?
Ensure brevity in your answer.  0.87. What is the ratio of the Education completion rate(%) of Lao PDR in 2007 to that in 2009?
Offer a very short reply. 0.93. What is the ratio of the Education completion rate(%) in Syrian Arab Republic in 2007 to that in 2009?
Offer a very short reply. 0.96. What is the ratio of the Education completion rate(%) of World in 2008 to that in 2009?
Your answer should be compact. 0.99. What is the ratio of the Education completion rate(%) in Dominica in 2008 to that in 2009?
Provide a short and direct response. 0.81. What is the ratio of the Education completion rate(%) in Lao PDR in 2008 to that in 2009?
Keep it short and to the point. 0.94. What is the ratio of the Education completion rate(%) in Syrian Arab Republic in 2008 to that in 2009?
Ensure brevity in your answer.  1.01. What is the difference between the highest and the second highest Education completion rate(%) in World?
Provide a succinct answer. 0.84. What is the difference between the highest and the second highest Education completion rate(%) in Dominica?
Give a very brief answer. 0.5. What is the difference between the highest and the second highest Education completion rate(%) in Lao PDR?
Provide a succinct answer. 1.03. What is the difference between the highest and the second highest Education completion rate(%) of Syrian Arab Republic?
Make the answer very short. 0.94. What is the difference between the highest and the lowest Education completion rate(%) in World?
Your answer should be very brief. 3.39. What is the difference between the highest and the lowest Education completion rate(%) of Dominica?
Your answer should be compact. 25.72. What is the difference between the highest and the lowest Education completion rate(%) of Lao PDR?
Give a very brief answer. 4.4. What is the difference between the highest and the lowest Education completion rate(%) in Syrian Arab Republic?
Your response must be concise. 6.74. 